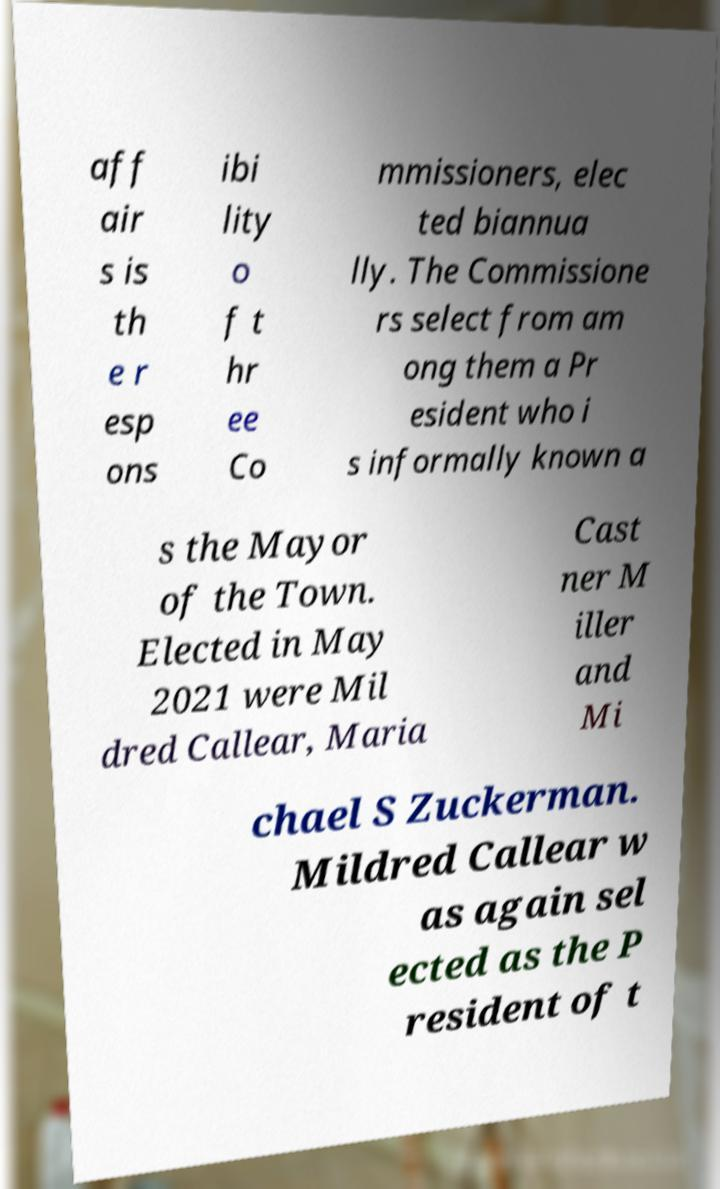Could you extract and type out the text from this image? aff air s is th e r esp ons ibi lity o f t hr ee Co mmissioners, elec ted biannua lly. The Commissione rs select from am ong them a Pr esident who i s informally known a s the Mayor of the Town. Elected in May 2021 were Mil dred Callear, Maria Cast ner M iller and Mi chael S Zuckerman. Mildred Callear w as again sel ected as the P resident of t 